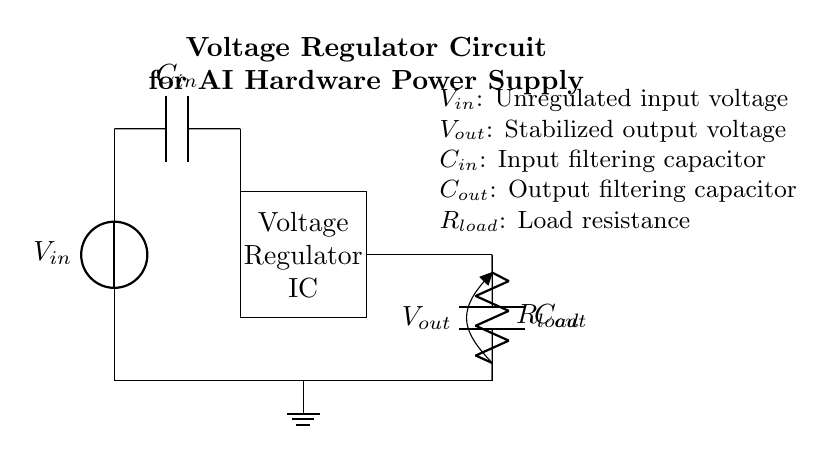What is the input voltage labeled in the circuit? The input voltage is labeled as \(V_{in}\), which indicates the unregulated voltage supplied to the circuit.
Answer: \(V_{in}\) What type of components are \(C_{in}\) and \(C_{out}\)? Both \(C_{in}\) and \(C_{out}\) are capacitors used for filtering; \(C_{in}\) filters the input voltage and \(C_{out}\) stabilizes the output voltage.
Answer: Capacitors What is the function of the voltage regulator IC? The voltage regulator IC stabilizes the output voltage \(V_{out}\) with respect to varying input voltages, ensuring a constant voltage supply for the load.
Answer: Stabilization How many capacitors are present in this circuit? There are two capacitors shown in the circuit: \(C_{in}\) for input filtering and \(C_{out}\) for output filtering.
Answer: 2 What does \(R_{load}\) represent in the circuit? \(R_{load}\) represents the load resistance, indicating the component or circuit that receives the output voltage \(V_{out}\) from the regulator.
Answer: Load resistance What happens to the output voltage when the input voltage varies? The output voltage \(V_{out}\) remains stable despite variations in the input voltage, thanks to the function of the voltage regulator IC.
Answer: Remains stable What is the role of the input capacitor \(C_{in}\)? The role of input capacitor \(C_{in}\) is to filter high-frequency noise and stabilize the input voltage coming into the regulator to ensure smooth operation.
Answer: Filter high-frequency noise 